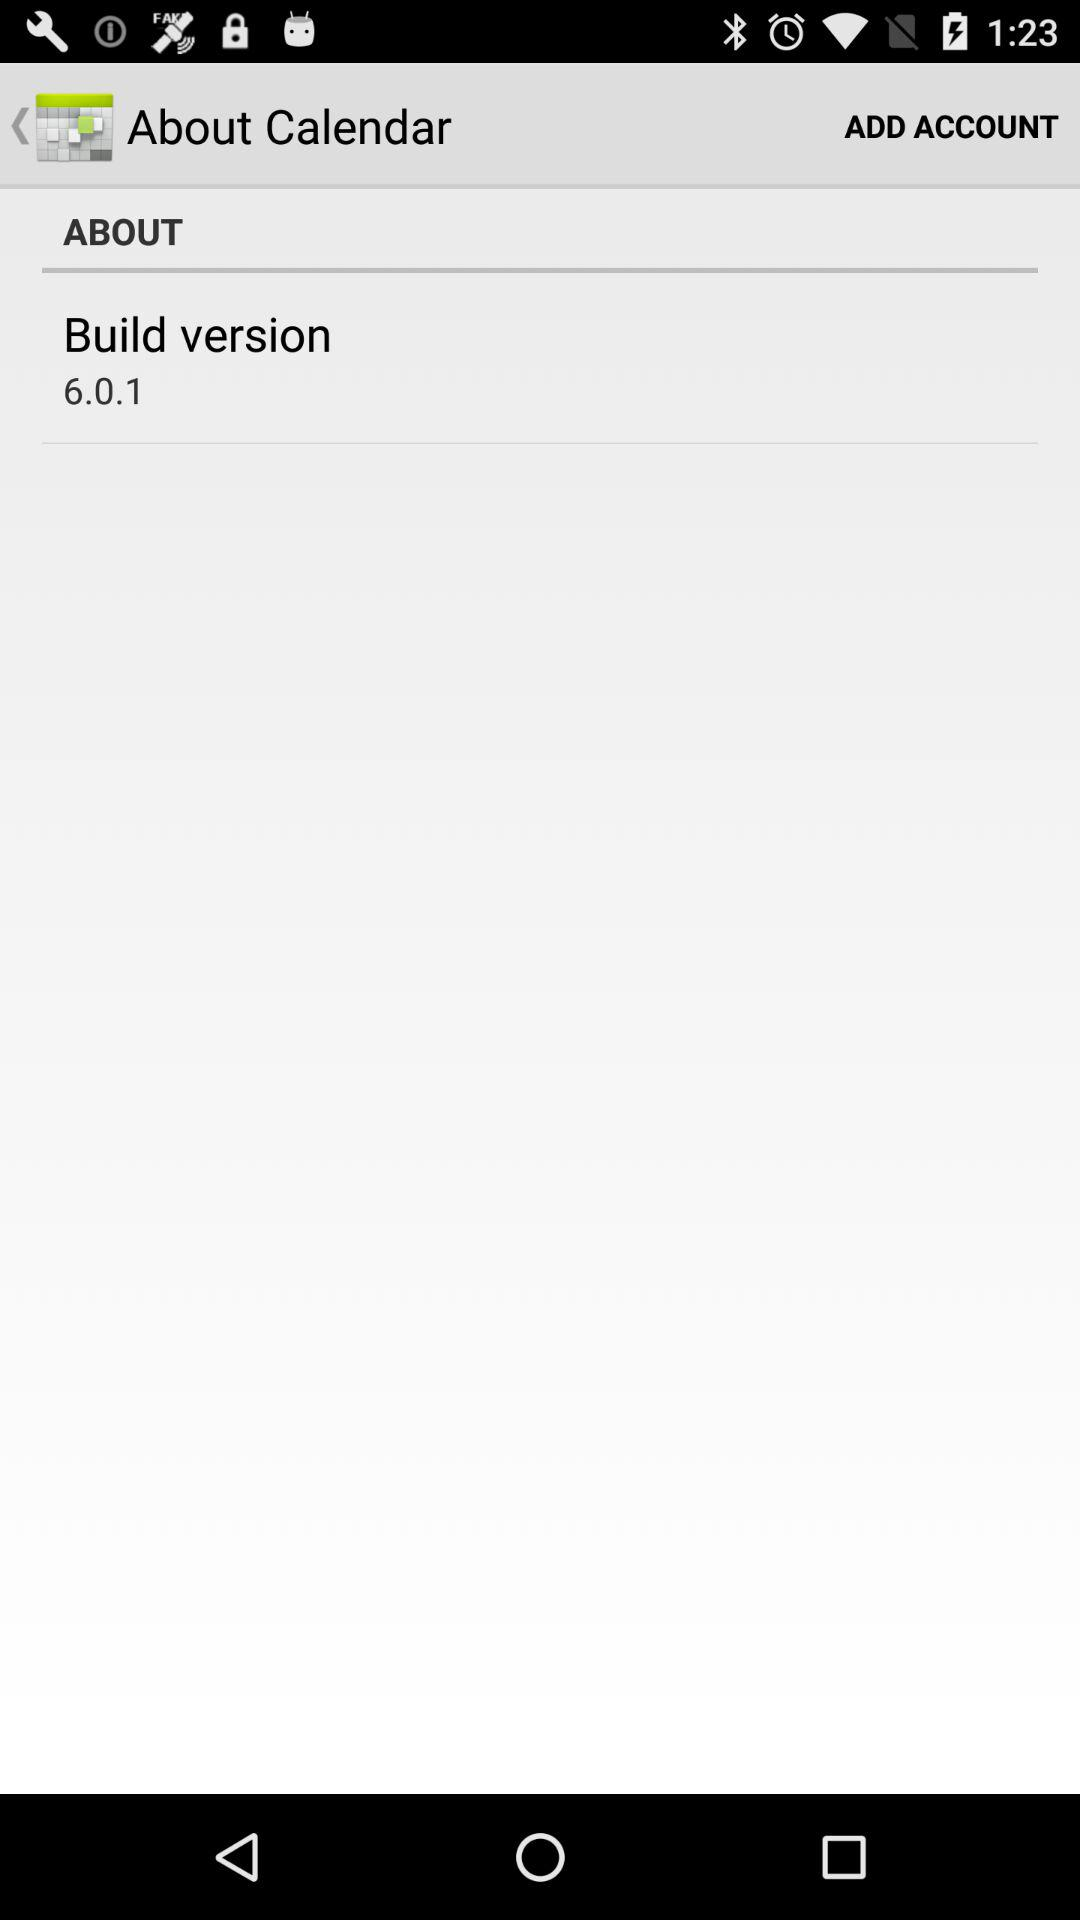What is the build version? The build version is 6.0.1. 